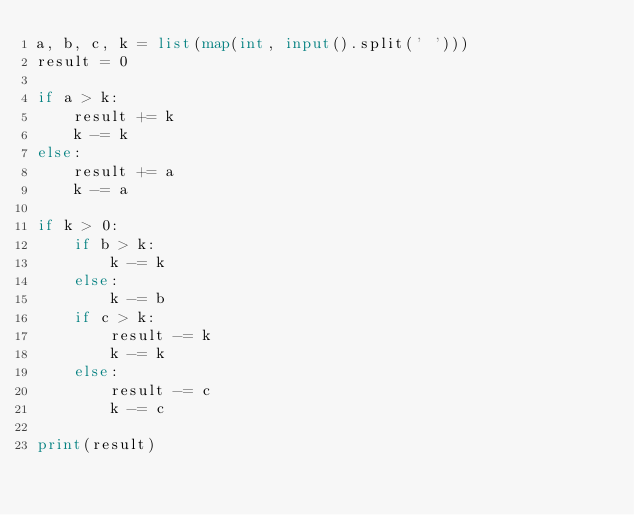Convert code to text. <code><loc_0><loc_0><loc_500><loc_500><_Python_>a, b, c, k = list(map(int, input().split(' ')))
result = 0

if a > k:
    result += k
    k -= k
else:
    result += a
    k -= a

if k > 0:
    if b > k:
        k -= k
    else:
        k -= b
    if c > k:
        result -= k
        k -= k
    else:
        result -= c
        k -= c

print(result)</code> 